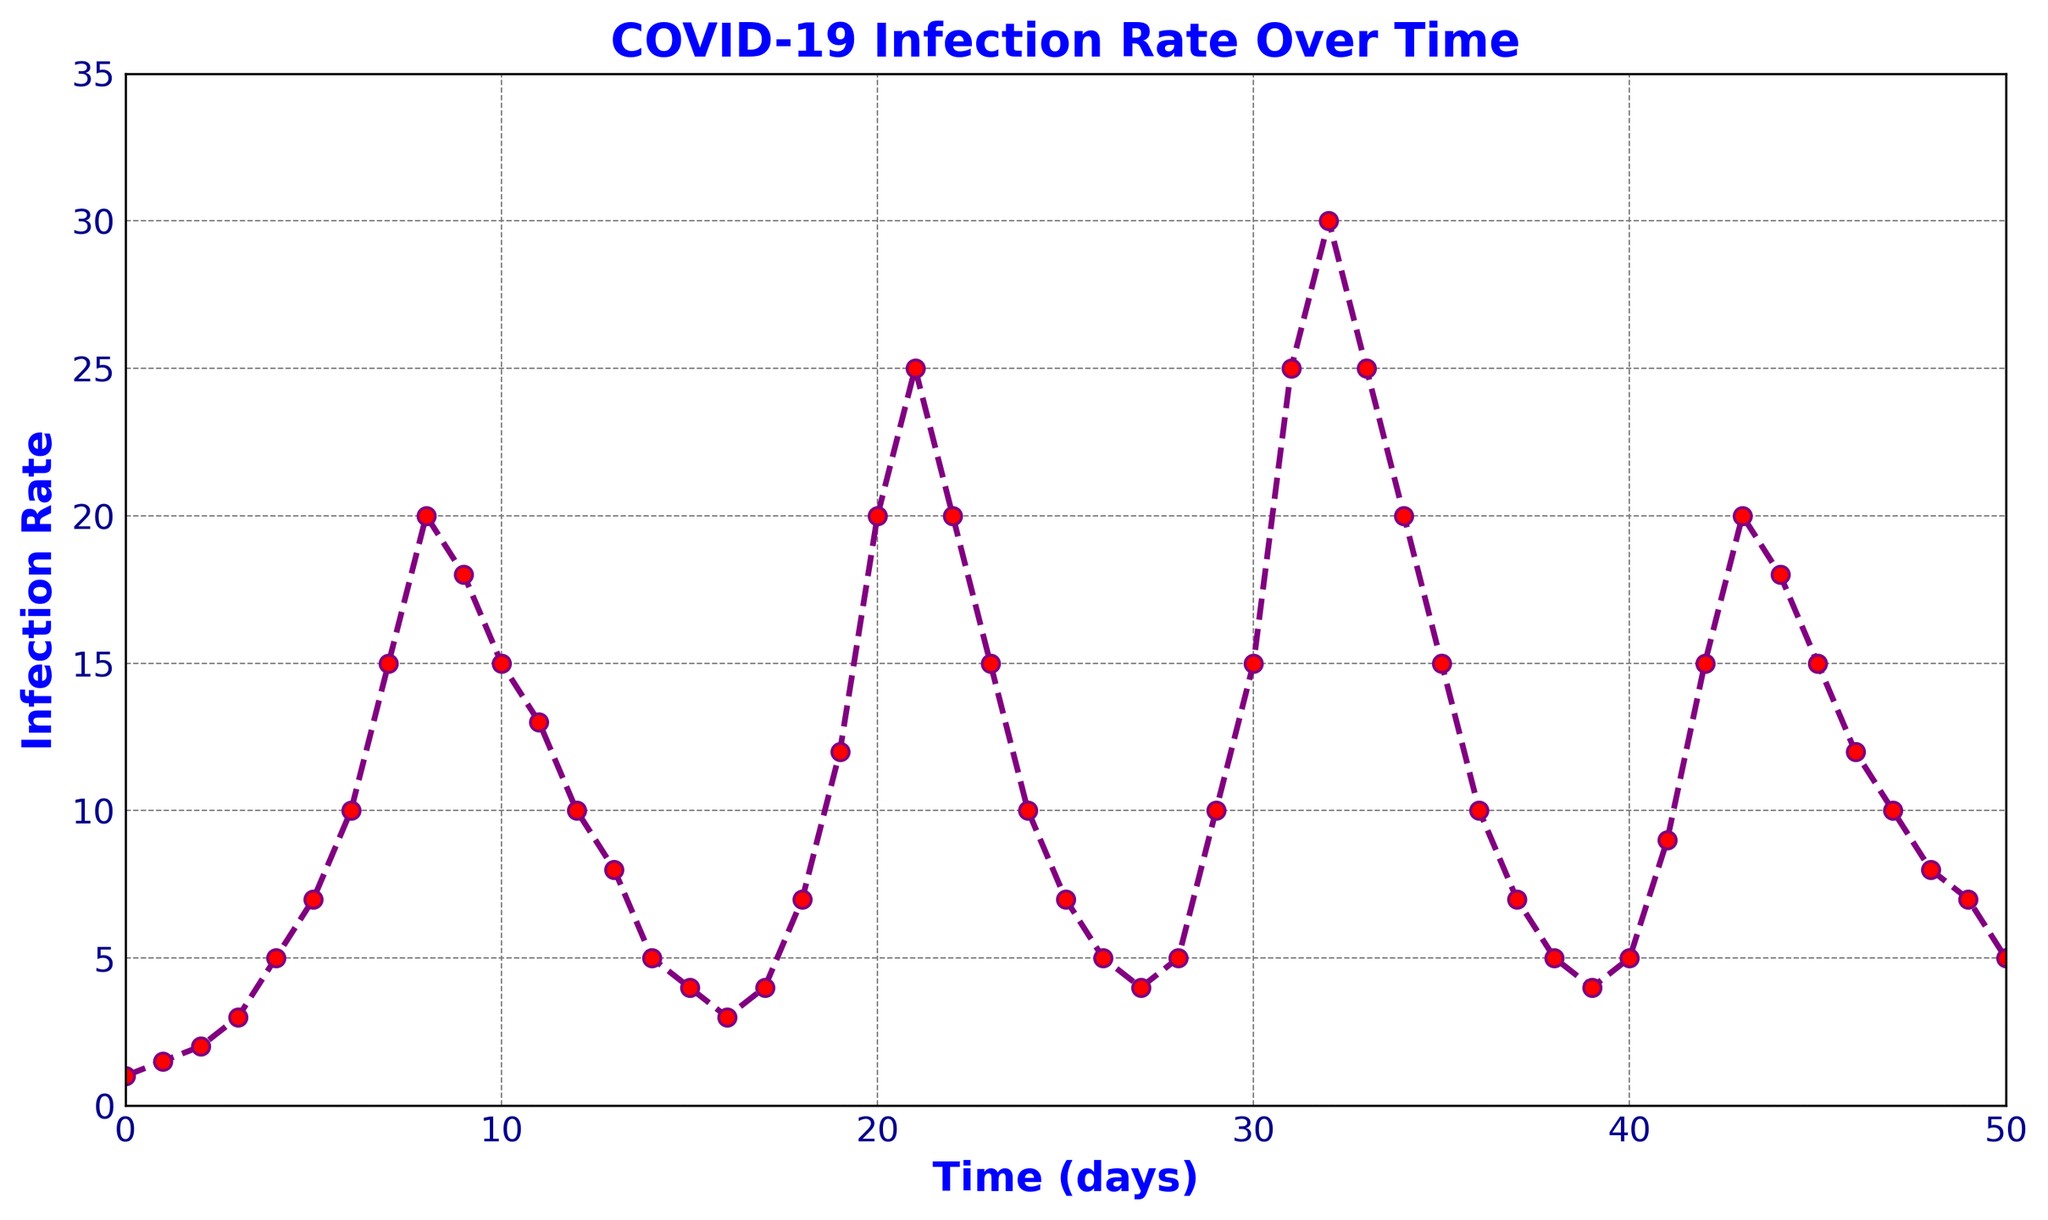What is the peak infection rate observed in the figure? To find the peak infection rate, look for the highest point on the plot. The highest point occurs at time = 32, where the infection rate is 30.
Answer: 30 When does the first significant decline in the infection rate occur after the initial rise? The initial rise starts at time = 0 and peaks at time = 8 with an infection rate of 20. The first significant decline happens from time = 8 to time = 9, where the infection rate drops from 20 to 18.
Answer: 9 Compare the infection rates at day 7 and day 27. Which is higher? Look at the infection rates on the y-axis at the corresponding time points. On day 7, the infection rate is 15, and on day 27, it is 4. Therefore, the infection rate on day 7 is higher.
Answer: Day 7 What is the average infection rate from day 10 to day 15? Sum the infection rates from day 10 to day 15: (15 + 13 + 10 + 8 + 5 + 4) = 55. Divide by the number of days (6): 55 / 6 = 9.17.
Answer: 9.17 What color is the line representing the infection rate? The line color can be seen directly from the figure. It is specified as purple.
Answer: Purple How many waves of infection can be visually identified in the figure? Visually inspect the plot for distinct peaks and valleys. The figure shows three distinct waves: one peaking around day 8, another around day 20, and the final one around day 32.
Answer: 3 Between which two consecutive days is the largest single-day increase in the infection rate? Compare the rates for each consecutive pair of days to find the maximum increase. The largest jump is from day 1 to day 2 (from 1.5 to 2), an increase of 0.5.
Answer: From day 1 to day 2 During which days does the infection rate remain constant, and what is the rate during this period? Inspect the figure to find constant rates. The infection rate remains constant from day 0 to day 1 at a rate of 1.
Answer: Days 0 to 1, Rate 1 